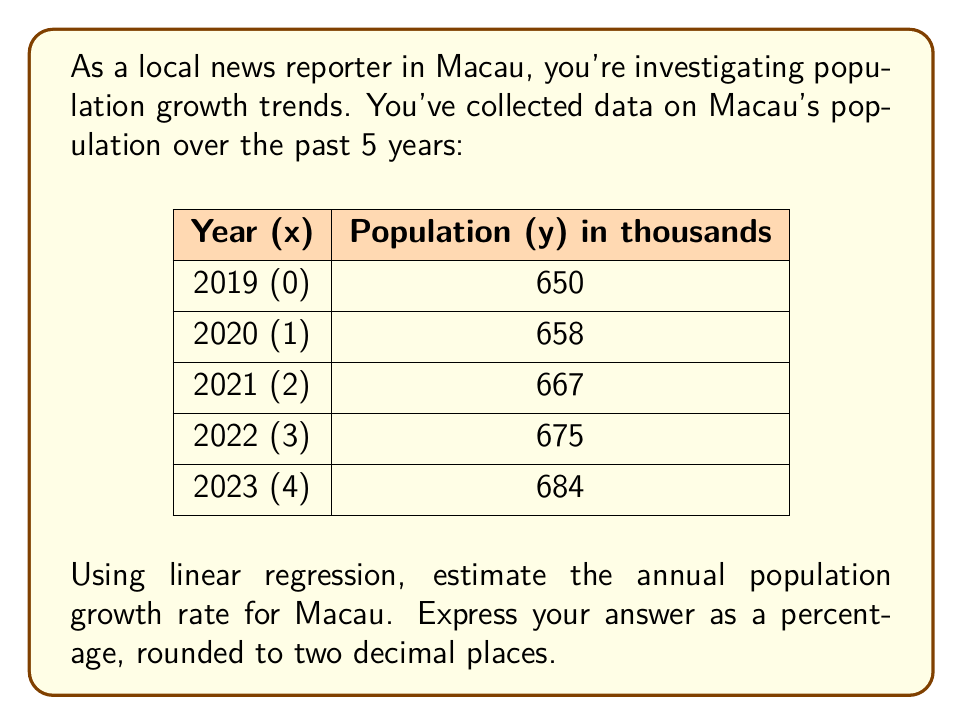Could you help me with this problem? To estimate the population growth rate using linear regression, we'll follow these steps:

1. Set up the linear regression equation: $y = mx + b$
   Where $y$ is the population, $x$ is the year, $m$ is the slope (annual growth), and $b$ is the y-intercept.

2. Calculate the means of x and y:
   $\bar{x} = \frac{0 + 1 + 2 + 3 + 4}{5} = 2$
   $\bar{y} = \frac{650 + 658 + 667 + 675 + 684}{5} = 666.8$

3. Calculate $\sum(x - \bar{x})(y - \bar{y})$ and $\sum(x - \bar{x})^2$:
   
   $\sum(x - \bar{x})(y - \bar{y}) = (-2)(-16.8) + (-1)(-8.8) + (0)(0.2) + (1)(8.2) + (2)(17.2) = 84$
   
   $\sum(x - \bar{x})^2 = (-2)^2 + (-1)^2 + 0^2 + 1^2 + 2^2 = 10$

4. Calculate the slope (m):
   $m = \frac{\sum(x - \bar{x})(y - \bar{y})}{\sum(x - \bar{x})^2} = \frac{84}{10} = 8.4$

5. The slope represents the average annual population increase in thousands.

6. To express this as a percentage growth rate, divide by the average population and multiply by 100:

   Growth rate = $\frac{8.4}{666.8} \times 100 = 1.26\%$
Answer: 1.26% 